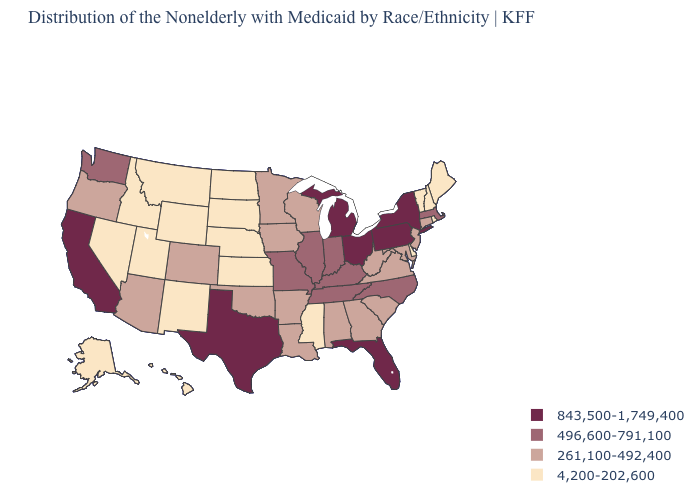Does the first symbol in the legend represent the smallest category?
Concise answer only. No. What is the highest value in the USA?
Short answer required. 843,500-1,749,400. What is the value of Maryland?
Be succinct. 261,100-492,400. Does the map have missing data?
Keep it brief. No. Does Connecticut have a higher value than Texas?
Answer briefly. No. Name the states that have a value in the range 261,100-492,400?
Quick response, please. Alabama, Arizona, Arkansas, Colorado, Connecticut, Georgia, Iowa, Louisiana, Maryland, Minnesota, New Jersey, Oklahoma, Oregon, South Carolina, Virginia, West Virginia, Wisconsin. What is the value of Wisconsin?
Write a very short answer. 261,100-492,400. Among the states that border South Dakota , does Iowa have the highest value?
Answer briefly. Yes. Among the states that border Colorado , does Kansas have the lowest value?
Keep it brief. Yes. What is the value of North Dakota?
Answer briefly. 4,200-202,600. Name the states that have a value in the range 496,600-791,100?
Concise answer only. Illinois, Indiana, Kentucky, Massachusetts, Missouri, North Carolina, Tennessee, Washington. What is the highest value in the MidWest ?
Answer briefly. 843,500-1,749,400. What is the value of Alaska?
Be succinct. 4,200-202,600. Does Colorado have a higher value than North Dakota?
Quick response, please. Yes. Name the states that have a value in the range 843,500-1,749,400?
Answer briefly. California, Florida, Michigan, New York, Ohio, Pennsylvania, Texas. 